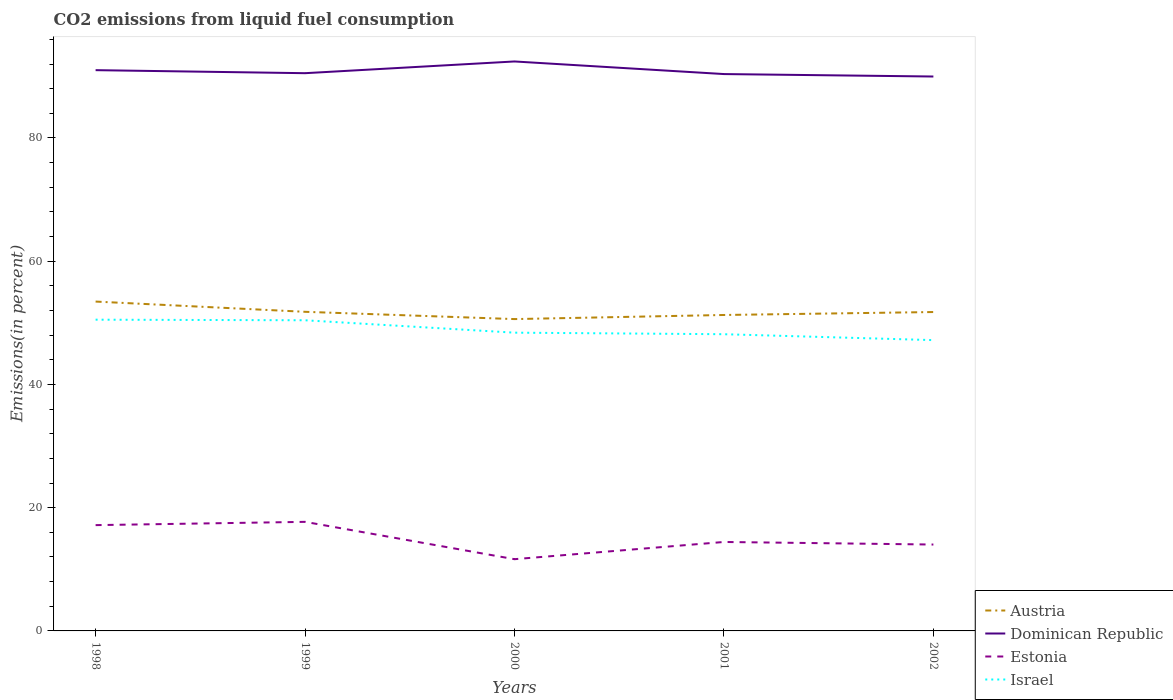Does the line corresponding to Estonia intersect with the line corresponding to Austria?
Offer a terse response. No. Across all years, what is the maximum total CO2 emitted in Dominican Republic?
Give a very brief answer. 89.98. What is the total total CO2 emitted in Israel in the graph?
Provide a succinct answer. 2.26. What is the difference between the highest and the second highest total CO2 emitted in Dominican Republic?
Provide a short and direct response. 2.44. Is the total CO2 emitted in Estonia strictly greater than the total CO2 emitted in Dominican Republic over the years?
Offer a terse response. Yes. How many years are there in the graph?
Your answer should be compact. 5. What is the difference between two consecutive major ticks on the Y-axis?
Offer a very short reply. 20. Where does the legend appear in the graph?
Offer a terse response. Bottom right. How are the legend labels stacked?
Offer a terse response. Vertical. What is the title of the graph?
Offer a terse response. CO2 emissions from liquid fuel consumption. What is the label or title of the Y-axis?
Your response must be concise. Emissions(in percent). What is the Emissions(in percent) in Austria in 1998?
Your answer should be compact. 53.45. What is the Emissions(in percent) in Dominican Republic in 1998?
Provide a succinct answer. 91.01. What is the Emissions(in percent) of Estonia in 1998?
Your answer should be very brief. 17.17. What is the Emissions(in percent) in Israel in 1998?
Provide a succinct answer. 50.51. What is the Emissions(in percent) in Austria in 1999?
Provide a succinct answer. 51.79. What is the Emissions(in percent) of Dominican Republic in 1999?
Your answer should be compact. 90.52. What is the Emissions(in percent) of Estonia in 1999?
Your response must be concise. 17.7. What is the Emissions(in percent) of Israel in 1999?
Offer a terse response. 50.42. What is the Emissions(in percent) of Austria in 2000?
Provide a succinct answer. 50.61. What is the Emissions(in percent) in Dominican Republic in 2000?
Offer a very short reply. 92.42. What is the Emissions(in percent) of Estonia in 2000?
Your answer should be very brief. 11.64. What is the Emissions(in percent) of Israel in 2000?
Make the answer very short. 48.41. What is the Emissions(in percent) in Austria in 2001?
Your answer should be compact. 51.28. What is the Emissions(in percent) of Dominican Republic in 2001?
Provide a succinct answer. 90.38. What is the Emissions(in percent) of Estonia in 2001?
Your answer should be compact. 14.44. What is the Emissions(in percent) in Israel in 2001?
Keep it short and to the point. 48.15. What is the Emissions(in percent) of Austria in 2002?
Your response must be concise. 51.75. What is the Emissions(in percent) of Dominican Republic in 2002?
Provide a succinct answer. 89.98. What is the Emissions(in percent) in Estonia in 2002?
Offer a very short reply. 14.02. What is the Emissions(in percent) of Israel in 2002?
Give a very brief answer. 47.2. Across all years, what is the maximum Emissions(in percent) of Austria?
Make the answer very short. 53.45. Across all years, what is the maximum Emissions(in percent) of Dominican Republic?
Your response must be concise. 92.42. Across all years, what is the maximum Emissions(in percent) of Estonia?
Offer a very short reply. 17.7. Across all years, what is the maximum Emissions(in percent) in Israel?
Your response must be concise. 50.51. Across all years, what is the minimum Emissions(in percent) of Austria?
Provide a short and direct response. 50.61. Across all years, what is the minimum Emissions(in percent) in Dominican Republic?
Your answer should be very brief. 89.98. Across all years, what is the minimum Emissions(in percent) of Estonia?
Give a very brief answer. 11.64. Across all years, what is the minimum Emissions(in percent) in Israel?
Keep it short and to the point. 47.2. What is the total Emissions(in percent) in Austria in the graph?
Provide a succinct answer. 258.89. What is the total Emissions(in percent) in Dominican Republic in the graph?
Offer a very short reply. 454.31. What is the total Emissions(in percent) in Estonia in the graph?
Provide a short and direct response. 74.97. What is the total Emissions(in percent) in Israel in the graph?
Your response must be concise. 244.69. What is the difference between the Emissions(in percent) in Austria in 1998 and that in 1999?
Provide a short and direct response. 1.66. What is the difference between the Emissions(in percent) of Dominican Republic in 1998 and that in 1999?
Your answer should be compact. 0.49. What is the difference between the Emissions(in percent) of Estonia in 1998 and that in 1999?
Your answer should be very brief. -0.53. What is the difference between the Emissions(in percent) of Israel in 1998 and that in 1999?
Your answer should be very brief. 0.1. What is the difference between the Emissions(in percent) of Austria in 1998 and that in 2000?
Offer a very short reply. 2.84. What is the difference between the Emissions(in percent) of Dominican Republic in 1998 and that in 2000?
Provide a succinct answer. -1.41. What is the difference between the Emissions(in percent) of Estonia in 1998 and that in 2000?
Your answer should be very brief. 5.53. What is the difference between the Emissions(in percent) in Israel in 1998 and that in 2000?
Ensure brevity in your answer.  2.11. What is the difference between the Emissions(in percent) of Austria in 1998 and that in 2001?
Offer a terse response. 2.18. What is the difference between the Emissions(in percent) in Dominican Republic in 1998 and that in 2001?
Give a very brief answer. 0.63. What is the difference between the Emissions(in percent) in Estonia in 1998 and that in 2001?
Provide a succinct answer. 2.73. What is the difference between the Emissions(in percent) in Israel in 1998 and that in 2001?
Your answer should be very brief. 2.36. What is the difference between the Emissions(in percent) of Austria in 1998 and that in 2002?
Your response must be concise. 1.7. What is the difference between the Emissions(in percent) in Dominican Republic in 1998 and that in 2002?
Make the answer very short. 1.03. What is the difference between the Emissions(in percent) of Estonia in 1998 and that in 2002?
Give a very brief answer. 3.15. What is the difference between the Emissions(in percent) of Israel in 1998 and that in 2002?
Ensure brevity in your answer.  3.32. What is the difference between the Emissions(in percent) in Austria in 1999 and that in 2000?
Give a very brief answer. 1.18. What is the difference between the Emissions(in percent) of Dominican Republic in 1999 and that in 2000?
Give a very brief answer. -1.9. What is the difference between the Emissions(in percent) in Estonia in 1999 and that in 2000?
Keep it short and to the point. 6.06. What is the difference between the Emissions(in percent) of Israel in 1999 and that in 2000?
Offer a terse response. 2.01. What is the difference between the Emissions(in percent) in Austria in 1999 and that in 2001?
Provide a succinct answer. 0.52. What is the difference between the Emissions(in percent) in Dominican Republic in 1999 and that in 2001?
Provide a short and direct response. 0.14. What is the difference between the Emissions(in percent) in Estonia in 1999 and that in 2001?
Offer a terse response. 3.27. What is the difference between the Emissions(in percent) of Israel in 1999 and that in 2001?
Provide a succinct answer. 2.26. What is the difference between the Emissions(in percent) in Austria in 1999 and that in 2002?
Your answer should be very brief. 0.04. What is the difference between the Emissions(in percent) in Dominican Republic in 1999 and that in 2002?
Provide a short and direct response. 0.54. What is the difference between the Emissions(in percent) of Estonia in 1999 and that in 2002?
Offer a terse response. 3.68. What is the difference between the Emissions(in percent) of Israel in 1999 and that in 2002?
Your answer should be compact. 3.22. What is the difference between the Emissions(in percent) of Austria in 2000 and that in 2001?
Keep it short and to the point. -0.67. What is the difference between the Emissions(in percent) in Dominican Republic in 2000 and that in 2001?
Your response must be concise. 2.04. What is the difference between the Emissions(in percent) of Estonia in 2000 and that in 2001?
Ensure brevity in your answer.  -2.79. What is the difference between the Emissions(in percent) in Israel in 2000 and that in 2001?
Keep it short and to the point. 0.25. What is the difference between the Emissions(in percent) in Austria in 2000 and that in 2002?
Ensure brevity in your answer.  -1.14. What is the difference between the Emissions(in percent) of Dominican Republic in 2000 and that in 2002?
Your answer should be very brief. 2.44. What is the difference between the Emissions(in percent) in Estonia in 2000 and that in 2002?
Ensure brevity in your answer.  -2.38. What is the difference between the Emissions(in percent) in Israel in 2000 and that in 2002?
Ensure brevity in your answer.  1.21. What is the difference between the Emissions(in percent) in Austria in 2001 and that in 2002?
Your answer should be very brief. -0.48. What is the difference between the Emissions(in percent) in Dominican Republic in 2001 and that in 2002?
Provide a short and direct response. 0.4. What is the difference between the Emissions(in percent) of Estonia in 2001 and that in 2002?
Your answer should be compact. 0.42. What is the difference between the Emissions(in percent) in Israel in 2001 and that in 2002?
Make the answer very short. 0.96. What is the difference between the Emissions(in percent) in Austria in 1998 and the Emissions(in percent) in Dominican Republic in 1999?
Your answer should be compact. -37.06. What is the difference between the Emissions(in percent) of Austria in 1998 and the Emissions(in percent) of Estonia in 1999?
Give a very brief answer. 35.75. What is the difference between the Emissions(in percent) in Austria in 1998 and the Emissions(in percent) in Israel in 1999?
Offer a very short reply. 3.03. What is the difference between the Emissions(in percent) of Dominican Republic in 1998 and the Emissions(in percent) of Estonia in 1999?
Ensure brevity in your answer.  73.31. What is the difference between the Emissions(in percent) of Dominican Republic in 1998 and the Emissions(in percent) of Israel in 1999?
Make the answer very short. 40.59. What is the difference between the Emissions(in percent) in Estonia in 1998 and the Emissions(in percent) in Israel in 1999?
Offer a very short reply. -33.25. What is the difference between the Emissions(in percent) of Austria in 1998 and the Emissions(in percent) of Dominican Republic in 2000?
Your response must be concise. -38.97. What is the difference between the Emissions(in percent) of Austria in 1998 and the Emissions(in percent) of Estonia in 2000?
Keep it short and to the point. 41.81. What is the difference between the Emissions(in percent) in Austria in 1998 and the Emissions(in percent) in Israel in 2000?
Offer a terse response. 5.05. What is the difference between the Emissions(in percent) in Dominican Republic in 1998 and the Emissions(in percent) in Estonia in 2000?
Your answer should be compact. 79.37. What is the difference between the Emissions(in percent) of Dominican Republic in 1998 and the Emissions(in percent) of Israel in 2000?
Offer a terse response. 42.6. What is the difference between the Emissions(in percent) in Estonia in 1998 and the Emissions(in percent) in Israel in 2000?
Provide a succinct answer. -31.24. What is the difference between the Emissions(in percent) of Austria in 1998 and the Emissions(in percent) of Dominican Republic in 2001?
Your response must be concise. -36.92. What is the difference between the Emissions(in percent) of Austria in 1998 and the Emissions(in percent) of Estonia in 2001?
Provide a succinct answer. 39.02. What is the difference between the Emissions(in percent) of Austria in 1998 and the Emissions(in percent) of Israel in 2001?
Provide a succinct answer. 5.3. What is the difference between the Emissions(in percent) of Dominican Republic in 1998 and the Emissions(in percent) of Estonia in 2001?
Keep it short and to the point. 76.57. What is the difference between the Emissions(in percent) of Dominican Republic in 1998 and the Emissions(in percent) of Israel in 2001?
Provide a short and direct response. 42.86. What is the difference between the Emissions(in percent) in Estonia in 1998 and the Emissions(in percent) in Israel in 2001?
Your answer should be very brief. -30.98. What is the difference between the Emissions(in percent) of Austria in 1998 and the Emissions(in percent) of Dominican Republic in 2002?
Your answer should be very brief. -36.52. What is the difference between the Emissions(in percent) in Austria in 1998 and the Emissions(in percent) in Estonia in 2002?
Your answer should be very brief. 39.43. What is the difference between the Emissions(in percent) in Austria in 1998 and the Emissions(in percent) in Israel in 2002?
Provide a short and direct response. 6.26. What is the difference between the Emissions(in percent) in Dominican Republic in 1998 and the Emissions(in percent) in Estonia in 2002?
Your answer should be compact. 76.99. What is the difference between the Emissions(in percent) of Dominican Republic in 1998 and the Emissions(in percent) of Israel in 2002?
Your response must be concise. 43.82. What is the difference between the Emissions(in percent) in Estonia in 1998 and the Emissions(in percent) in Israel in 2002?
Your answer should be compact. -30.03. What is the difference between the Emissions(in percent) in Austria in 1999 and the Emissions(in percent) in Dominican Republic in 2000?
Your response must be concise. -40.63. What is the difference between the Emissions(in percent) in Austria in 1999 and the Emissions(in percent) in Estonia in 2000?
Your answer should be very brief. 40.15. What is the difference between the Emissions(in percent) of Austria in 1999 and the Emissions(in percent) of Israel in 2000?
Give a very brief answer. 3.39. What is the difference between the Emissions(in percent) in Dominican Republic in 1999 and the Emissions(in percent) in Estonia in 2000?
Your response must be concise. 78.88. What is the difference between the Emissions(in percent) of Dominican Republic in 1999 and the Emissions(in percent) of Israel in 2000?
Ensure brevity in your answer.  42.11. What is the difference between the Emissions(in percent) of Estonia in 1999 and the Emissions(in percent) of Israel in 2000?
Provide a short and direct response. -30.7. What is the difference between the Emissions(in percent) in Austria in 1999 and the Emissions(in percent) in Dominican Republic in 2001?
Provide a short and direct response. -38.59. What is the difference between the Emissions(in percent) in Austria in 1999 and the Emissions(in percent) in Estonia in 2001?
Your response must be concise. 37.35. What is the difference between the Emissions(in percent) of Austria in 1999 and the Emissions(in percent) of Israel in 2001?
Your answer should be compact. 3.64. What is the difference between the Emissions(in percent) in Dominican Republic in 1999 and the Emissions(in percent) in Estonia in 2001?
Offer a very short reply. 76.08. What is the difference between the Emissions(in percent) of Dominican Republic in 1999 and the Emissions(in percent) of Israel in 2001?
Offer a terse response. 42.36. What is the difference between the Emissions(in percent) in Estonia in 1999 and the Emissions(in percent) in Israel in 2001?
Provide a succinct answer. -30.45. What is the difference between the Emissions(in percent) of Austria in 1999 and the Emissions(in percent) of Dominican Republic in 2002?
Keep it short and to the point. -38.19. What is the difference between the Emissions(in percent) of Austria in 1999 and the Emissions(in percent) of Estonia in 2002?
Ensure brevity in your answer.  37.77. What is the difference between the Emissions(in percent) of Austria in 1999 and the Emissions(in percent) of Israel in 2002?
Offer a terse response. 4.6. What is the difference between the Emissions(in percent) in Dominican Republic in 1999 and the Emissions(in percent) in Estonia in 2002?
Offer a very short reply. 76.5. What is the difference between the Emissions(in percent) in Dominican Republic in 1999 and the Emissions(in percent) in Israel in 2002?
Offer a very short reply. 43.32. What is the difference between the Emissions(in percent) in Estonia in 1999 and the Emissions(in percent) in Israel in 2002?
Ensure brevity in your answer.  -29.49. What is the difference between the Emissions(in percent) of Austria in 2000 and the Emissions(in percent) of Dominican Republic in 2001?
Give a very brief answer. -39.77. What is the difference between the Emissions(in percent) of Austria in 2000 and the Emissions(in percent) of Estonia in 2001?
Your response must be concise. 36.17. What is the difference between the Emissions(in percent) of Austria in 2000 and the Emissions(in percent) of Israel in 2001?
Make the answer very short. 2.46. What is the difference between the Emissions(in percent) in Dominican Republic in 2000 and the Emissions(in percent) in Estonia in 2001?
Make the answer very short. 77.98. What is the difference between the Emissions(in percent) of Dominican Republic in 2000 and the Emissions(in percent) of Israel in 2001?
Provide a short and direct response. 44.27. What is the difference between the Emissions(in percent) in Estonia in 2000 and the Emissions(in percent) in Israel in 2001?
Keep it short and to the point. -36.51. What is the difference between the Emissions(in percent) of Austria in 2000 and the Emissions(in percent) of Dominican Republic in 2002?
Ensure brevity in your answer.  -39.37. What is the difference between the Emissions(in percent) of Austria in 2000 and the Emissions(in percent) of Estonia in 2002?
Provide a succinct answer. 36.59. What is the difference between the Emissions(in percent) of Austria in 2000 and the Emissions(in percent) of Israel in 2002?
Keep it short and to the point. 3.41. What is the difference between the Emissions(in percent) of Dominican Republic in 2000 and the Emissions(in percent) of Estonia in 2002?
Provide a succinct answer. 78.4. What is the difference between the Emissions(in percent) of Dominican Republic in 2000 and the Emissions(in percent) of Israel in 2002?
Your answer should be compact. 45.23. What is the difference between the Emissions(in percent) of Estonia in 2000 and the Emissions(in percent) of Israel in 2002?
Ensure brevity in your answer.  -35.55. What is the difference between the Emissions(in percent) of Austria in 2001 and the Emissions(in percent) of Dominican Republic in 2002?
Give a very brief answer. -38.7. What is the difference between the Emissions(in percent) of Austria in 2001 and the Emissions(in percent) of Estonia in 2002?
Provide a short and direct response. 37.26. What is the difference between the Emissions(in percent) of Austria in 2001 and the Emissions(in percent) of Israel in 2002?
Your answer should be compact. 4.08. What is the difference between the Emissions(in percent) of Dominican Republic in 2001 and the Emissions(in percent) of Estonia in 2002?
Your response must be concise. 76.36. What is the difference between the Emissions(in percent) of Dominican Republic in 2001 and the Emissions(in percent) of Israel in 2002?
Your answer should be compact. 43.18. What is the difference between the Emissions(in percent) of Estonia in 2001 and the Emissions(in percent) of Israel in 2002?
Give a very brief answer. -32.76. What is the average Emissions(in percent) in Austria per year?
Give a very brief answer. 51.78. What is the average Emissions(in percent) in Dominican Republic per year?
Offer a terse response. 90.86. What is the average Emissions(in percent) in Estonia per year?
Ensure brevity in your answer.  14.99. What is the average Emissions(in percent) in Israel per year?
Keep it short and to the point. 48.94. In the year 1998, what is the difference between the Emissions(in percent) in Austria and Emissions(in percent) in Dominican Republic?
Offer a terse response. -37.56. In the year 1998, what is the difference between the Emissions(in percent) of Austria and Emissions(in percent) of Estonia?
Give a very brief answer. 36.28. In the year 1998, what is the difference between the Emissions(in percent) of Austria and Emissions(in percent) of Israel?
Your response must be concise. 2.94. In the year 1998, what is the difference between the Emissions(in percent) of Dominican Republic and Emissions(in percent) of Estonia?
Offer a very short reply. 73.84. In the year 1998, what is the difference between the Emissions(in percent) in Dominican Republic and Emissions(in percent) in Israel?
Offer a very short reply. 40.5. In the year 1998, what is the difference between the Emissions(in percent) in Estonia and Emissions(in percent) in Israel?
Offer a terse response. -33.34. In the year 1999, what is the difference between the Emissions(in percent) of Austria and Emissions(in percent) of Dominican Republic?
Your answer should be very brief. -38.73. In the year 1999, what is the difference between the Emissions(in percent) of Austria and Emissions(in percent) of Estonia?
Keep it short and to the point. 34.09. In the year 1999, what is the difference between the Emissions(in percent) in Austria and Emissions(in percent) in Israel?
Your answer should be very brief. 1.37. In the year 1999, what is the difference between the Emissions(in percent) in Dominican Republic and Emissions(in percent) in Estonia?
Ensure brevity in your answer.  72.82. In the year 1999, what is the difference between the Emissions(in percent) in Dominican Republic and Emissions(in percent) in Israel?
Your answer should be compact. 40.1. In the year 1999, what is the difference between the Emissions(in percent) in Estonia and Emissions(in percent) in Israel?
Your answer should be compact. -32.72. In the year 2000, what is the difference between the Emissions(in percent) in Austria and Emissions(in percent) in Dominican Republic?
Your answer should be compact. -41.81. In the year 2000, what is the difference between the Emissions(in percent) of Austria and Emissions(in percent) of Estonia?
Give a very brief answer. 38.97. In the year 2000, what is the difference between the Emissions(in percent) in Austria and Emissions(in percent) in Israel?
Make the answer very short. 2.2. In the year 2000, what is the difference between the Emissions(in percent) of Dominican Republic and Emissions(in percent) of Estonia?
Provide a short and direct response. 80.78. In the year 2000, what is the difference between the Emissions(in percent) in Dominican Republic and Emissions(in percent) in Israel?
Offer a terse response. 44.02. In the year 2000, what is the difference between the Emissions(in percent) in Estonia and Emissions(in percent) in Israel?
Your response must be concise. -36.76. In the year 2001, what is the difference between the Emissions(in percent) of Austria and Emissions(in percent) of Dominican Republic?
Ensure brevity in your answer.  -39.1. In the year 2001, what is the difference between the Emissions(in percent) in Austria and Emissions(in percent) in Estonia?
Keep it short and to the point. 36.84. In the year 2001, what is the difference between the Emissions(in percent) in Austria and Emissions(in percent) in Israel?
Your response must be concise. 3.12. In the year 2001, what is the difference between the Emissions(in percent) of Dominican Republic and Emissions(in percent) of Estonia?
Your answer should be very brief. 75.94. In the year 2001, what is the difference between the Emissions(in percent) of Dominican Republic and Emissions(in percent) of Israel?
Your answer should be compact. 42.22. In the year 2001, what is the difference between the Emissions(in percent) of Estonia and Emissions(in percent) of Israel?
Your answer should be very brief. -33.72. In the year 2002, what is the difference between the Emissions(in percent) of Austria and Emissions(in percent) of Dominican Republic?
Provide a succinct answer. -38.22. In the year 2002, what is the difference between the Emissions(in percent) in Austria and Emissions(in percent) in Estonia?
Your response must be concise. 37.74. In the year 2002, what is the difference between the Emissions(in percent) of Austria and Emissions(in percent) of Israel?
Provide a short and direct response. 4.56. In the year 2002, what is the difference between the Emissions(in percent) of Dominican Republic and Emissions(in percent) of Estonia?
Provide a succinct answer. 75.96. In the year 2002, what is the difference between the Emissions(in percent) of Dominican Republic and Emissions(in percent) of Israel?
Keep it short and to the point. 42.78. In the year 2002, what is the difference between the Emissions(in percent) in Estonia and Emissions(in percent) in Israel?
Keep it short and to the point. -33.18. What is the ratio of the Emissions(in percent) in Austria in 1998 to that in 1999?
Provide a short and direct response. 1.03. What is the ratio of the Emissions(in percent) in Dominican Republic in 1998 to that in 1999?
Ensure brevity in your answer.  1.01. What is the ratio of the Emissions(in percent) of Estonia in 1998 to that in 1999?
Your response must be concise. 0.97. What is the ratio of the Emissions(in percent) in Austria in 1998 to that in 2000?
Make the answer very short. 1.06. What is the ratio of the Emissions(in percent) in Dominican Republic in 1998 to that in 2000?
Provide a short and direct response. 0.98. What is the ratio of the Emissions(in percent) of Estonia in 1998 to that in 2000?
Give a very brief answer. 1.47. What is the ratio of the Emissions(in percent) in Israel in 1998 to that in 2000?
Make the answer very short. 1.04. What is the ratio of the Emissions(in percent) in Austria in 1998 to that in 2001?
Make the answer very short. 1.04. What is the ratio of the Emissions(in percent) of Estonia in 1998 to that in 2001?
Keep it short and to the point. 1.19. What is the ratio of the Emissions(in percent) of Israel in 1998 to that in 2001?
Offer a very short reply. 1.05. What is the ratio of the Emissions(in percent) in Austria in 1998 to that in 2002?
Make the answer very short. 1.03. What is the ratio of the Emissions(in percent) of Dominican Republic in 1998 to that in 2002?
Offer a terse response. 1.01. What is the ratio of the Emissions(in percent) of Estonia in 1998 to that in 2002?
Your response must be concise. 1.22. What is the ratio of the Emissions(in percent) in Israel in 1998 to that in 2002?
Your answer should be compact. 1.07. What is the ratio of the Emissions(in percent) of Austria in 1999 to that in 2000?
Make the answer very short. 1.02. What is the ratio of the Emissions(in percent) of Dominican Republic in 1999 to that in 2000?
Offer a terse response. 0.98. What is the ratio of the Emissions(in percent) in Estonia in 1999 to that in 2000?
Provide a short and direct response. 1.52. What is the ratio of the Emissions(in percent) in Israel in 1999 to that in 2000?
Offer a very short reply. 1.04. What is the ratio of the Emissions(in percent) of Austria in 1999 to that in 2001?
Provide a succinct answer. 1.01. What is the ratio of the Emissions(in percent) in Estonia in 1999 to that in 2001?
Provide a succinct answer. 1.23. What is the ratio of the Emissions(in percent) in Israel in 1999 to that in 2001?
Your answer should be very brief. 1.05. What is the ratio of the Emissions(in percent) of Austria in 1999 to that in 2002?
Provide a succinct answer. 1. What is the ratio of the Emissions(in percent) of Estonia in 1999 to that in 2002?
Offer a terse response. 1.26. What is the ratio of the Emissions(in percent) of Israel in 1999 to that in 2002?
Make the answer very short. 1.07. What is the ratio of the Emissions(in percent) of Austria in 2000 to that in 2001?
Your answer should be very brief. 0.99. What is the ratio of the Emissions(in percent) of Dominican Republic in 2000 to that in 2001?
Offer a very short reply. 1.02. What is the ratio of the Emissions(in percent) in Estonia in 2000 to that in 2001?
Your response must be concise. 0.81. What is the ratio of the Emissions(in percent) of Israel in 2000 to that in 2001?
Offer a very short reply. 1.01. What is the ratio of the Emissions(in percent) of Austria in 2000 to that in 2002?
Offer a very short reply. 0.98. What is the ratio of the Emissions(in percent) in Dominican Republic in 2000 to that in 2002?
Your response must be concise. 1.03. What is the ratio of the Emissions(in percent) in Estonia in 2000 to that in 2002?
Keep it short and to the point. 0.83. What is the ratio of the Emissions(in percent) of Israel in 2000 to that in 2002?
Offer a terse response. 1.03. What is the ratio of the Emissions(in percent) in Dominican Republic in 2001 to that in 2002?
Keep it short and to the point. 1. What is the ratio of the Emissions(in percent) in Estonia in 2001 to that in 2002?
Make the answer very short. 1.03. What is the ratio of the Emissions(in percent) of Israel in 2001 to that in 2002?
Offer a terse response. 1.02. What is the difference between the highest and the second highest Emissions(in percent) in Austria?
Provide a short and direct response. 1.66. What is the difference between the highest and the second highest Emissions(in percent) of Dominican Republic?
Keep it short and to the point. 1.41. What is the difference between the highest and the second highest Emissions(in percent) in Estonia?
Give a very brief answer. 0.53. What is the difference between the highest and the second highest Emissions(in percent) in Israel?
Keep it short and to the point. 0.1. What is the difference between the highest and the lowest Emissions(in percent) of Austria?
Make the answer very short. 2.84. What is the difference between the highest and the lowest Emissions(in percent) of Dominican Republic?
Give a very brief answer. 2.44. What is the difference between the highest and the lowest Emissions(in percent) in Estonia?
Ensure brevity in your answer.  6.06. What is the difference between the highest and the lowest Emissions(in percent) of Israel?
Your answer should be very brief. 3.32. 